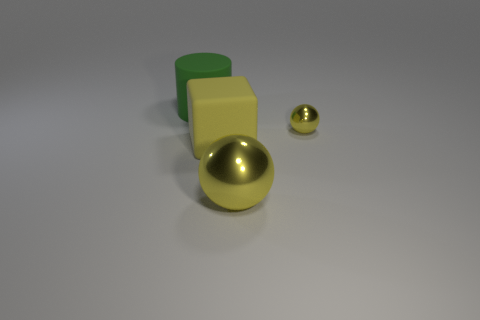Is the number of large metallic balls that are to the left of the large yellow metallic sphere less than the number of big green shiny objects?
Your answer should be very brief. No. What shape is the thing that is the same material as the yellow block?
Your response must be concise. Cylinder. Does the yellow metallic object behind the rubber cube have the same shape as the yellow thing that is in front of the large yellow rubber object?
Your response must be concise. Yes. Is the number of small metal spheres right of the tiny thing less than the number of green objects left of the big green matte cylinder?
Offer a terse response. No. What is the shape of the small shiny object that is the same color as the large shiny ball?
Ensure brevity in your answer.  Sphere. What number of blocks are the same size as the yellow rubber thing?
Provide a short and direct response. 0. Do the yellow object that is to the left of the large sphere and the small object have the same material?
Make the answer very short. No. Is there a green cube?
Your response must be concise. No. There is a yellow cube that is made of the same material as the large cylinder; what is its size?
Your answer should be very brief. Large. Is there a big cylinder of the same color as the cube?
Your answer should be compact. No. 